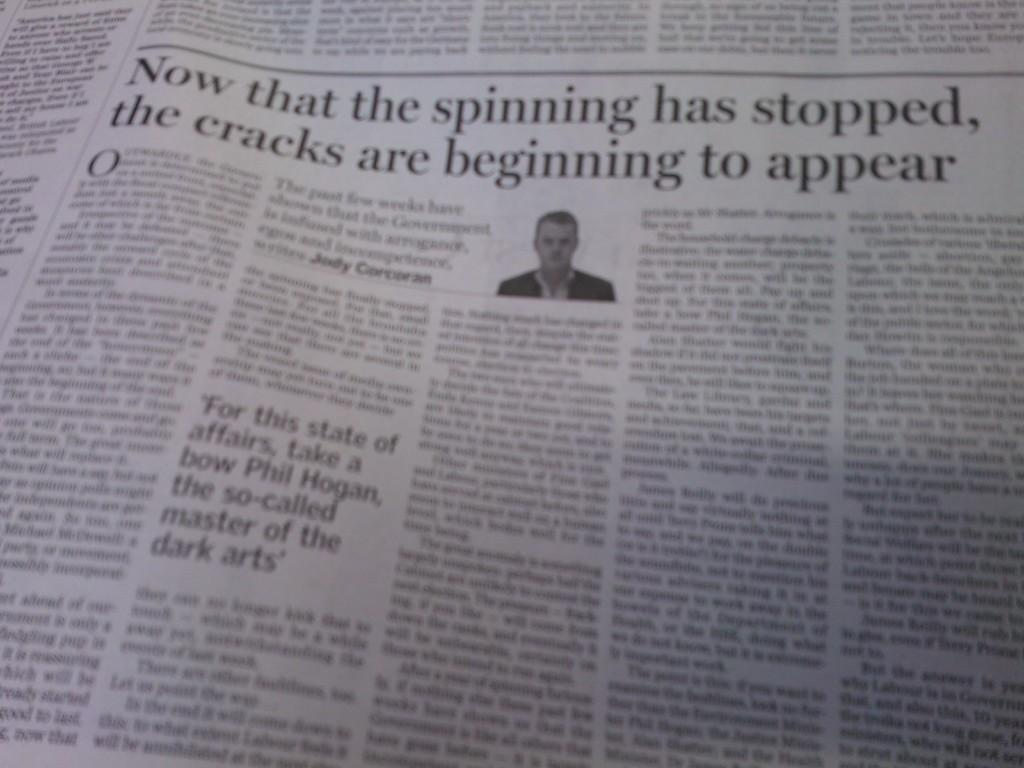What type of publication does the image come from? The image is from a newspaper. What can be found in the image from the newspaper? There is an article in the image. Who is mentioned in the article? The article contains a man. What is included in the article besides the man? The article contains some text. What is the sister of the man in the article doing in the image? There is no mention of a sister in the article or the image, so it cannot be determined what the sister might be doing. 